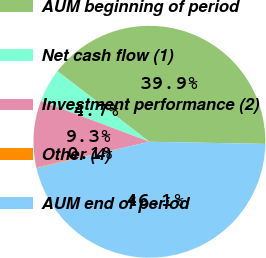Convert chart to OTSL. <chart><loc_0><loc_0><loc_500><loc_500><pie_chart><fcel>AUM beginning of period<fcel>Net cash flow (1)<fcel>Investment performance (2)<fcel>Other (4)<fcel>AUM end of period<nl><fcel>39.87%<fcel>4.69%<fcel>9.28%<fcel>0.09%<fcel>46.07%<nl></chart> 